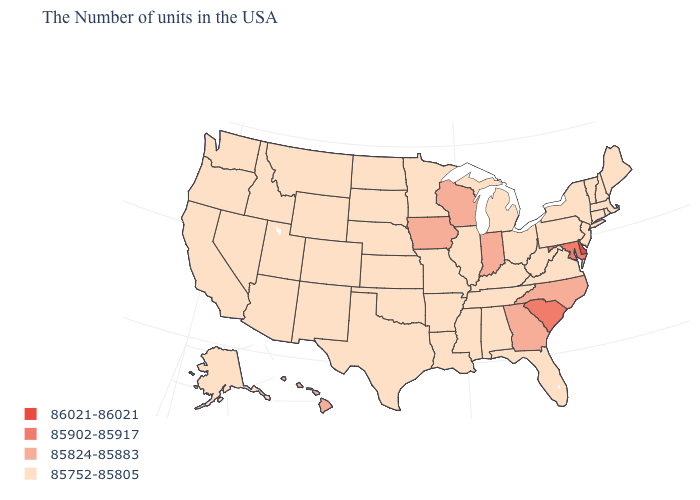Name the states that have a value in the range 85752-85805?
Keep it brief. Maine, Massachusetts, Rhode Island, New Hampshire, Vermont, Connecticut, New York, New Jersey, Pennsylvania, Virginia, West Virginia, Ohio, Florida, Michigan, Kentucky, Alabama, Tennessee, Illinois, Mississippi, Louisiana, Missouri, Arkansas, Minnesota, Kansas, Nebraska, Oklahoma, Texas, South Dakota, North Dakota, Wyoming, Colorado, New Mexico, Utah, Montana, Arizona, Idaho, Nevada, California, Washington, Oregon, Alaska. How many symbols are there in the legend?
Answer briefly. 4. Which states hav the highest value in the South?
Write a very short answer. Delaware. Name the states that have a value in the range 85752-85805?
Give a very brief answer. Maine, Massachusetts, Rhode Island, New Hampshire, Vermont, Connecticut, New York, New Jersey, Pennsylvania, Virginia, West Virginia, Ohio, Florida, Michigan, Kentucky, Alabama, Tennessee, Illinois, Mississippi, Louisiana, Missouri, Arkansas, Minnesota, Kansas, Nebraska, Oklahoma, Texas, South Dakota, North Dakota, Wyoming, Colorado, New Mexico, Utah, Montana, Arizona, Idaho, Nevada, California, Washington, Oregon, Alaska. Name the states that have a value in the range 85902-85917?
Give a very brief answer. Maryland, South Carolina. Name the states that have a value in the range 86021-86021?
Be succinct. Delaware. What is the value of Maine?
Write a very short answer. 85752-85805. Does Illinois have the highest value in the MidWest?
Concise answer only. No. Does Kansas have a higher value than Indiana?
Give a very brief answer. No. Does Mississippi have a lower value than North Carolina?
Quick response, please. Yes. What is the value of Florida?
Short answer required. 85752-85805. What is the value of Colorado?
Write a very short answer. 85752-85805. What is the value of Nevada?
Write a very short answer. 85752-85805. Does California have the lowest value in the USA?
Concise answer only. Yes. Which states have the lowest value in the Northeast?
Write a very short answer. Maine, Massachusetts, Rhode Island, New Hampshire, Vermont, Connecticut, New York, New Jersey, Pennsylvania. 